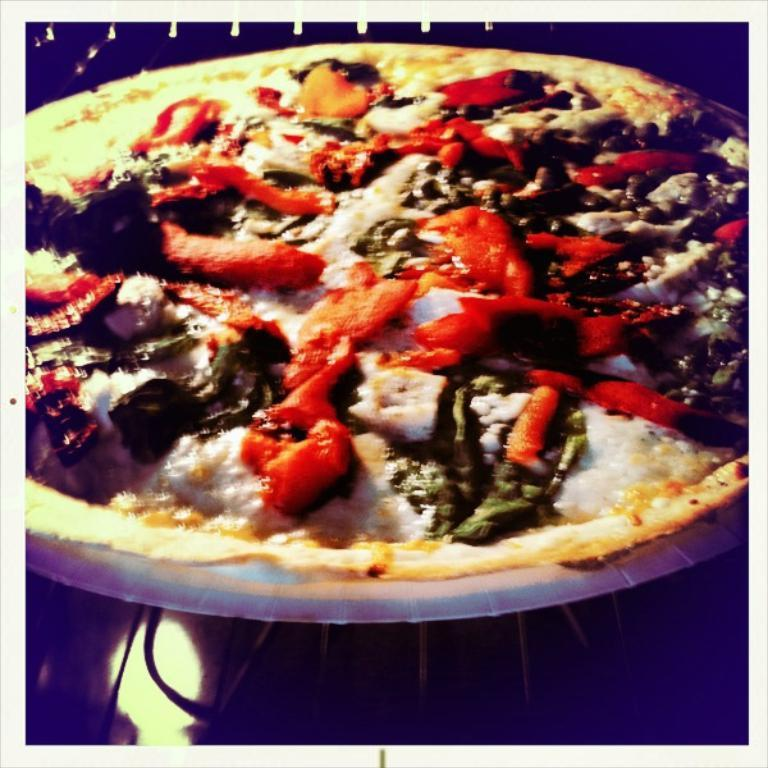What is the main subject of the image? The main subject of the image is a food item on a plate. Where is the plate located in the image? The plate is on a platform in the image. What type of rhythm can be heard coming from the church in the image? There is no church or any sounds mentioned in the image, so it's not possible to determine what type of rhythm might be heard. 